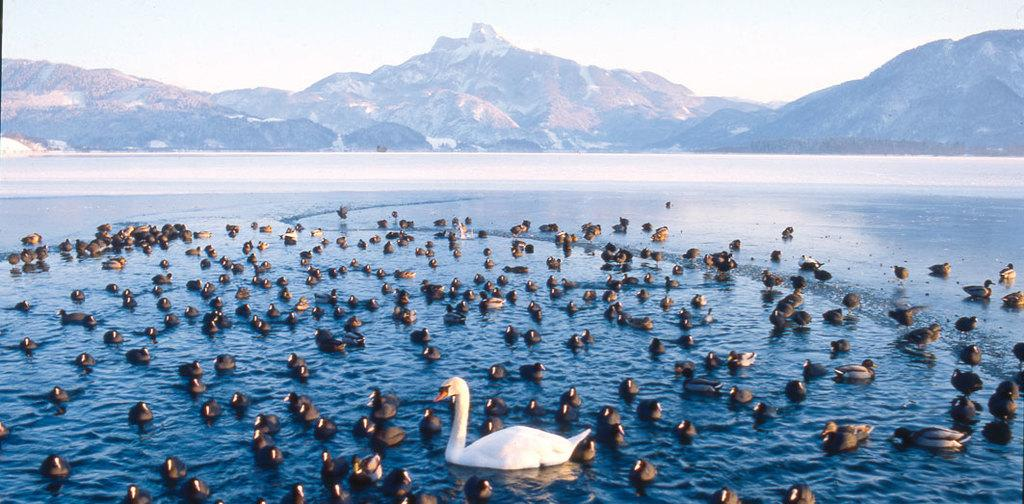What type of animals are in the water in the image? There are ducks in the water in the image. What can be seen in the background of the image? Hills and the sky are visible in the background of the image. What type of house can be seen in the image? There is no house present in the image; it features ducks in the water with hills and the sky visible in the background. 